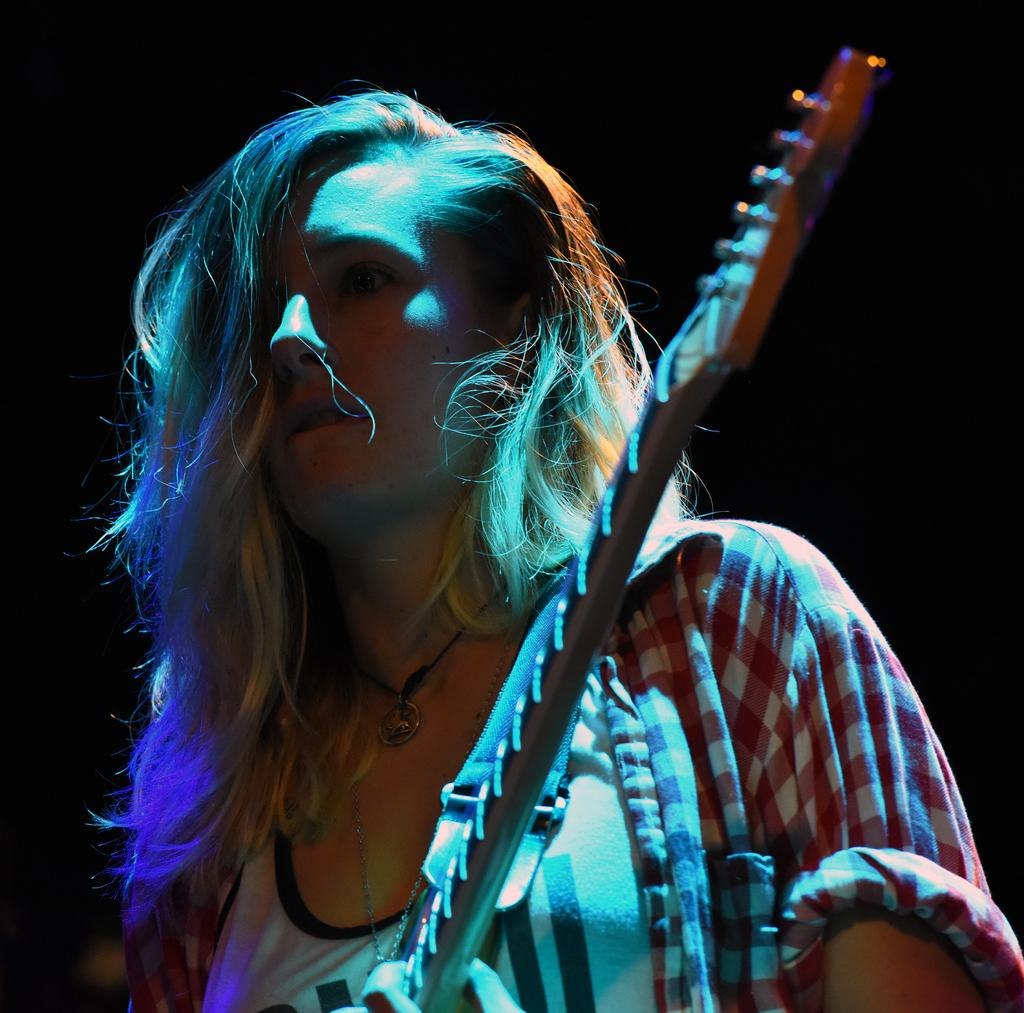Who is present in the image? There is a girl in the image. What object can be seen with the girl? There is a guitar in the image. How many bikes are visible in the image? There are no bikes present in the image. What type of thing is the girl holding in the image? The girl is holding a guitar in the image, not a "thing." How long does it take for the girl to play the guitar in the image? The image does not provide information about the duration of the girl playing the guitar, so it is not possible to answer that question. 